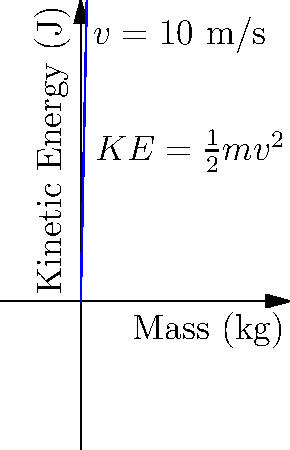In a rugby tackle, a player with a mass of 80 kg runs at a speed of 10 m/s before impact. Using the graph, estimate the kinetic energy of the player just before the tackle. How much energy is potentially transferred during the collision? To solve this problem, we'll follow these steps:

1) The kinetic energy of an object is given by the formula:
   $$ KE = \frac{1}{2}mv^2 $$
   where $m$ is the mass and $v$ is the velocity.

2) We're given:
   - Mass $(m) = 80$ kg
   - Velocity $(v) = 10$ m/s

3) Let's substitute these values into the equation:
   $$ KE = \frac{1}{2} \times 80 \times 10^2 $$
   $$ KE = 40 \times 100 $$
   $$ KE = 4000 \text{ J} $$

4) We can verify this result using the graph. Find the point where the mass is 80 kg, and read the corresponding kinetic energy value. It should be close to 4000 J.

5) During the collision, this kinetic energy will be transferred to other forms of energy (like heat, sound, and deformation of bodies). In an ideal scenario, all of this energy could potentially be transferred during the tackle.

Therefore, the kinetic energy of the player just before the tackle, which is also the maximum amount of energy that could be transferred during the collision, is approximately 4000 J.
Answer: 4000 J 